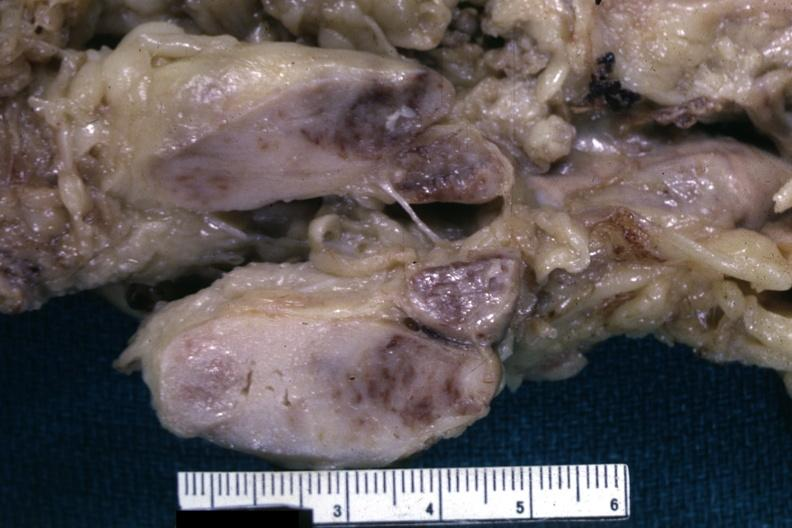what is present?
Answer the question using a single word or phrase. Lymph node 